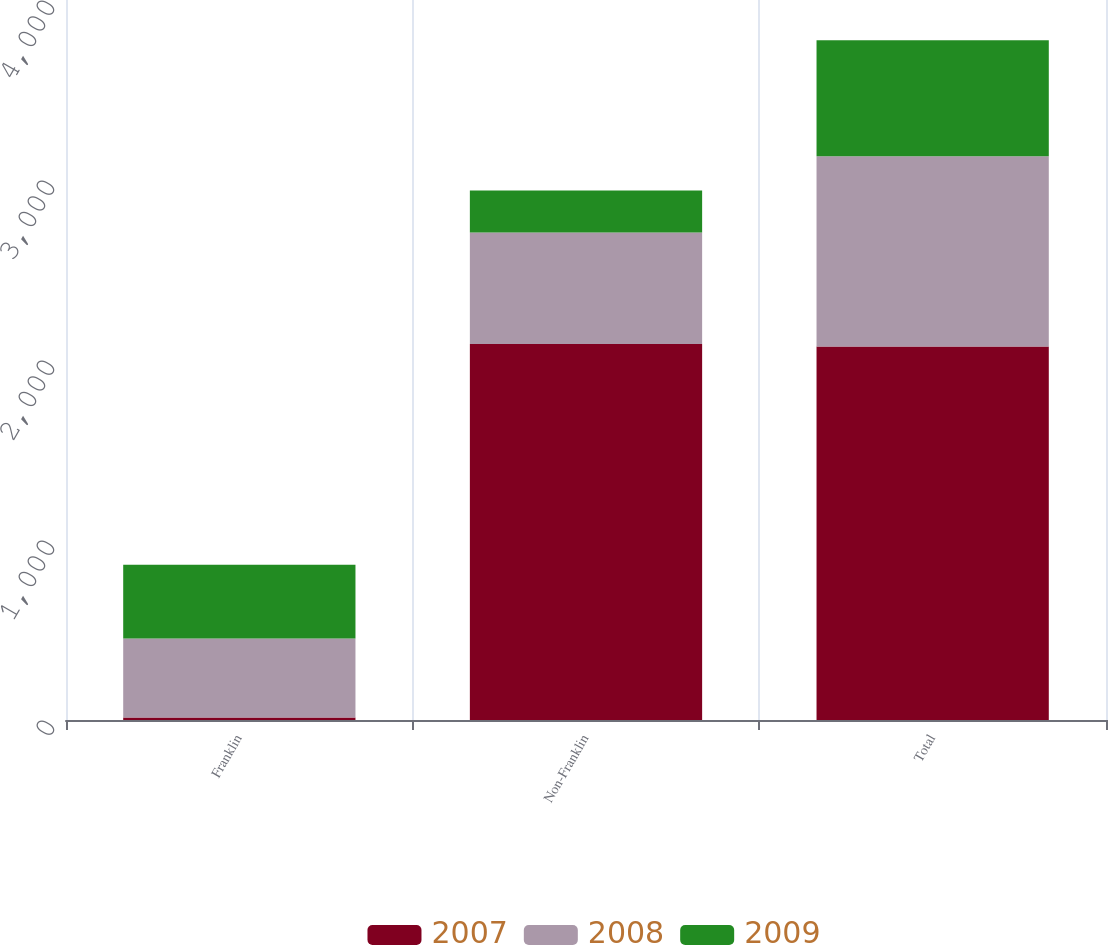<chart> <loc_0><loc_0><loc_500><loc_500><stacked_bar_chart><ecel><fcel>Franklin<fcel>Non-Franklin<fcel>Total<nl><fcel>2007<fcel>14.1<fcel>2088.8<fcel>2074.7<nl><fcel>2008<fcel>438<fcel>619.5<fcel>1057.5<nl><fcel>2009<fcel>410.8<fcel>232.8<fcel>643.6<nl></chart> 